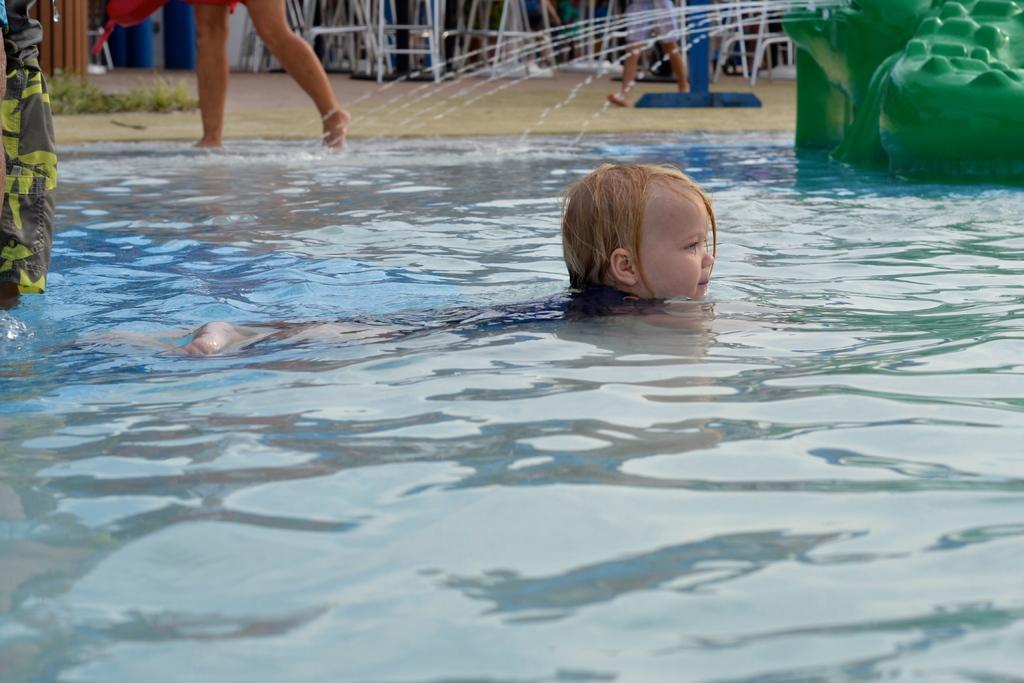Can you describe this image briefly? In this image we can see water, person and other objects. In the background of the image there are persons, grass and other objects. 